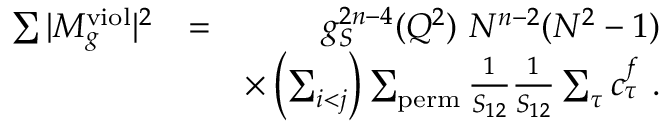<formula> <loc_0><loc_0><loc_500><loc_500>\begin{array} { r l r } { \sum | M _ { g } ^ { v i o l } | ^ { 2 } } & { = } & { g _ { S } ^ { 2 n - 4 } ( Q ^ { 2 } ) N ^ { n - 2 } ( N ^ { 2 } - 1 ) } \\ & { \times \left ( \sum _ { i < j } \right ) \sum _ { p e r m } \frac { 1 } { S _ { 1 2 } } \frac { 1 } { S _ { 1 2 } } \sum _ { \tau } c _ { \tau } ^ { f } . } \end{array}</formula> 